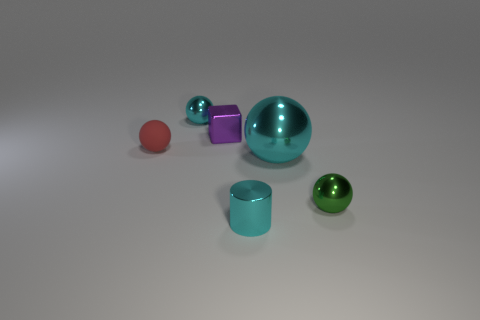Subtract 1 spheres. How many spheres are left? 3 Subtract all green spheres. How many spheres are left? 3 Subtract all big cyan shiny balls. How many balls are left? 3 Subtract all yellow balls. Subtract all blue cylinders. How many balls are left? 4 Add 4 small brown rubber objects. How many objects exist? 10 Subtract all cylinders. How many objects are left? 5 Add 6 small green rubber cylinders. How many small green rubber cylinders exist? 6 Subtract 0 blue balls. How many objects are left? 6 Subtract all purple metal cubes. Subtract all tiny green objects. How many objects are left? 4 Add 4 big objects. How many big objects are left? 5 